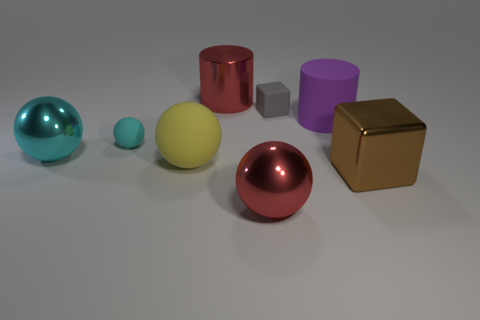Do the purple matte thing and the yellow rubber thing have the same shape?
Your answer should be very brief. No. Is there anything else that is the same color as the tiny rubber cube?
Make the answer very short. No. What shape is the metal thing that is both on the right side of the big cyan sphere and left of the red ball?
Provide a short and direct response. Cylinder. Are there an equal number of large cylinders behind the red cylinder and tiny gray objects to the left of the gray matte cube?
Provide a short and direct response. Yes. What number of cylinders are big brown metallic things or yellow things?
Your response must be concise. 0. What number of big red things are the same material as the large yellow thing?
Your answer should be very brief. 0. What shape is the large object that is the same color as the large metal cylinder?
Provide a short and direct response. Sphere. What is the material of the object that is behind the small cyan ball and left of the small gray thing?
Make the answer very short. Metal. What shape is the red object that is to the right of the large shiny cylinder?
Give a very brief answer. Sphere. What is the shape of the big red metallic object behind the tiny cyan rubber ball that is behind the brown block?
Offer a very short reply. Cylinder. 